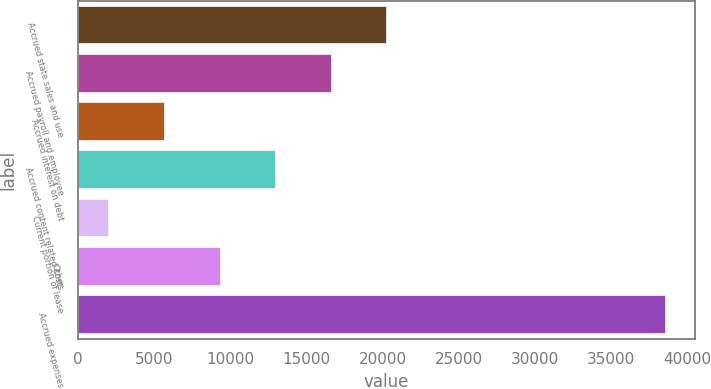<chart> <loc_0><loc_0><loc_500><loc_500><bar_chart><fcel>Accrued state sales and use<fcel>Accrued payroll and employee<fcel>Accrued interest on debt<fcel>Accrued content related costs<fcel>Current portion of lease<fcel>Other<fcel>Accrued expenses<nl><fcel>20327.5<fcel>16678.6<fcel>5731.9<fcel>13029.7<fcel>2083<fcel>9380.8<fcel>38572<nl></chart> 